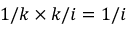Convert formula to latex. <formula><loc_0><loc_0><loc_500><loc_500>1 / k \times k / i = 1 / i</formula> 